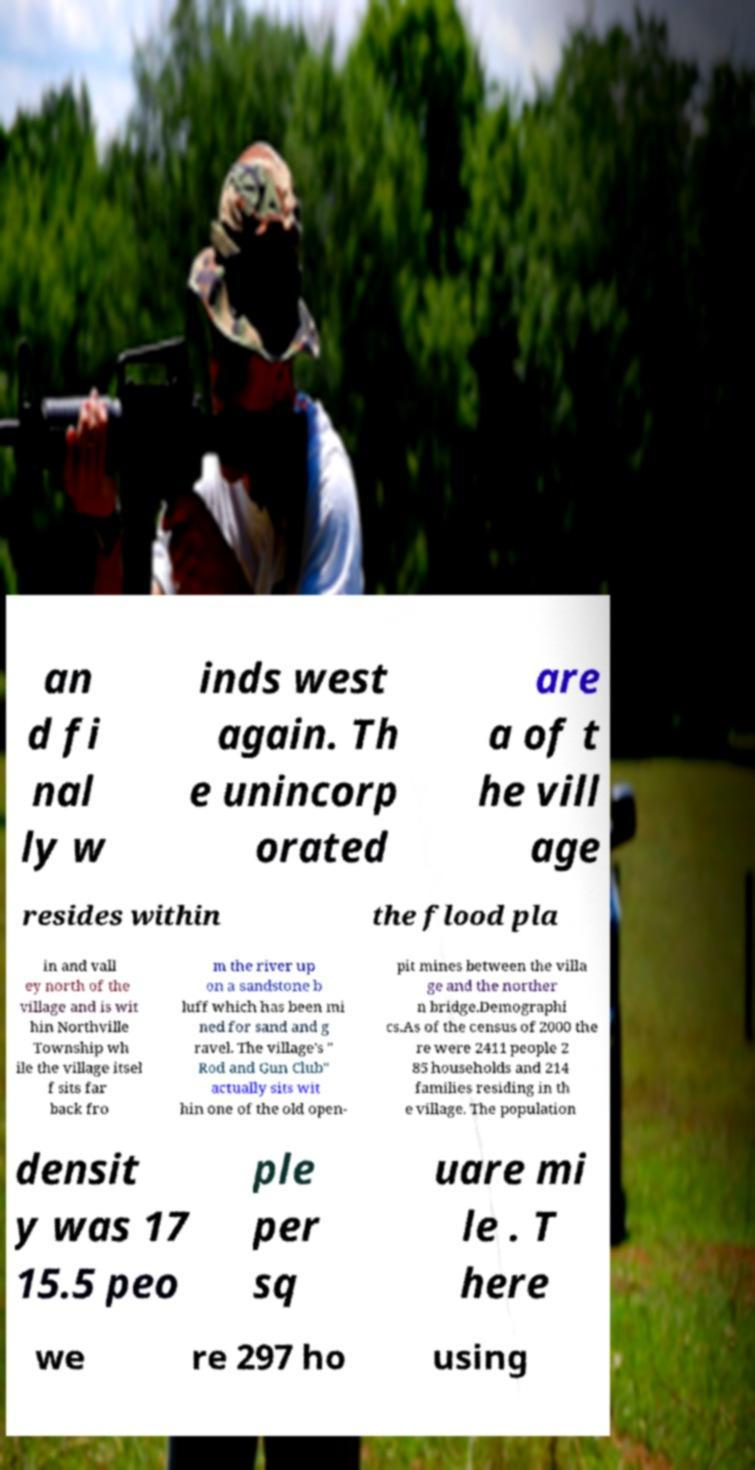There's text embedded in this image that I need extracted. Can you transcribe it verbatim? an d fi nal ly w inds west again. Th e unincorp orated are a of t he vill age resides within the flood pla in and vall ey north of the village and is wit hin Northville Township wh ile the village itsel f sits far back fro m the river up on a sandstone b luff which has been mi ned for sand and g ravel. The village's " Rod and Gun Club" actually sits wit hin one of the old open- pit mines between the villa ge and the norther n bridge.Demographi cs.As of the census of 2000 the re were 2411 people 2 85 households and 214 families residing in th e village. The population densit y was 17 15.5 peo ple per sq uare mi le . T here we re 297 ho using 